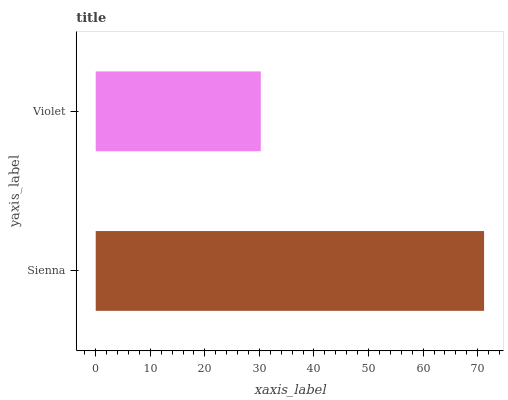Is Violet the minimum?
Answer yes or no. Yes. Is Sienna the maximum?
Answer yes or no. Yes. Is Violet the maximum?
Answer yes or no. No. Is Sienna greater than Violet?
Answer yes or no. Yes. Is Violet less than Sienna?
Answer yes or no. Yes. Is Violet greater than Sienna?
Answer yes or no. No. Is Sienna less than Violet?
Answer yes or no. No. Is Sienna the high median?
Answer yes or no. Yes. Is Violet the low median?
Answer yes or no. Yes. Is Violet the high median?
Answer yes or no. No. Is Sienna the low median?
Answer yes or no. No. 